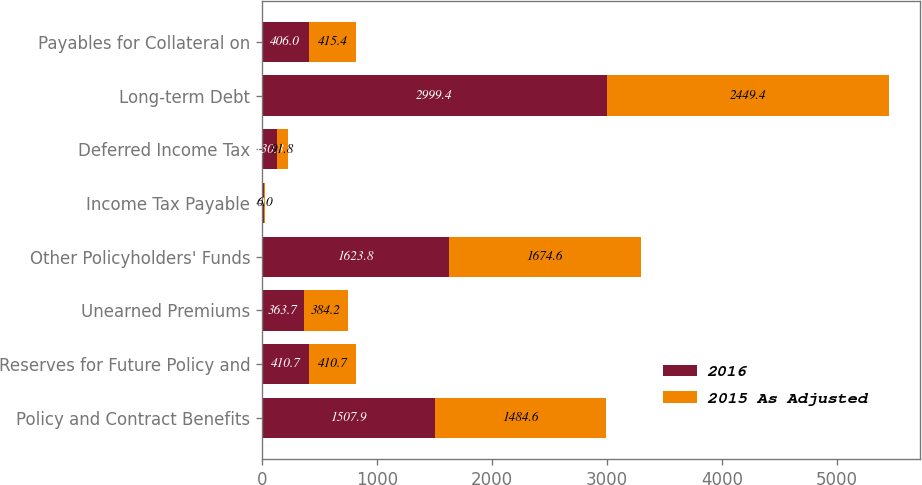<chart> <loc_0><loc_0><loc_500><loc_500><stacked_bar_chart><ecel><fcel>Policy and Contract Benefits<fcel>Reserves for Future Policy and<fcel>Unearned Premiums<fcel>Other Policyholders' Funds<fcel>Income Tax Payable<fcel>Deferred Income Tax<fcel>Long-term Debt<fcel>Payables for Collateral on<nl><fcel>2016<fcel>1507.9<fcel>410.7<fcel>363.7<fcel>1623.8<fcel>20.6<fcel>130.3<fcel>2999.4<fcel>406<nl><fcel>2015 As Adjusted<fcel>1484.6<fcel>410.7<fcel>384.2<fcel>1674.6<fcel>6<fcel>91.8<fcel>2449.4<fcel>415.4<nl></chart> 